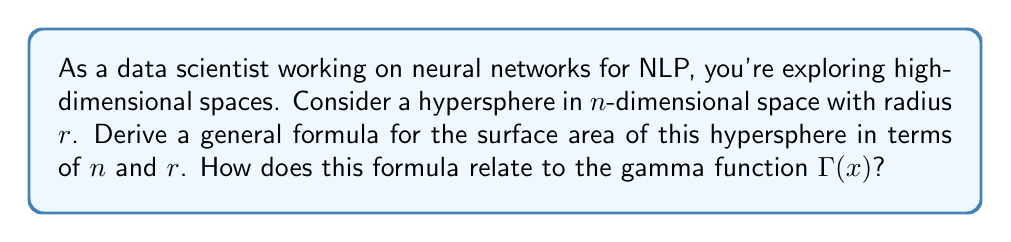Solve this math problem. To derive the surface area of a hypersphere in n-dimensional space, we'll follow these steps:

1) First, recall that the volume of a hypersphere in n-dimensions is given by:

   $$V_n(r) = \frac{\pi^{n/2}}{\Gamma(\frac{n}{2} + 1)} r^n$$

   where $\Gamma(x)$ is the gamma function.

2) The surface area of a hypersphere is the derivative of its volume with respect to radius:

   $$S_n(r) = \frac{d}{dr}V_n(r)$$

3) Applying the derivative:

   $$S_n(r) = \frac{d}{dr}\left(\frac{\pi^{n/2}}{\Gamma(\frac{n}{2} + 1)} r^n\right)$$

   $$S_n(r) = \frac{\pi^{n/2}}{\Gamma(\frac{n}{2} + 1)} \cdot n \cdot r^{n-1}$$

4) This can be simplified to:

   $$S_n(r) = \frac{n\pi^{n/2}}{\Gamma(\frac{n}{2} + 1)} r^{n-1}$$

5) The relation to the gamma function is evident in the denominator. The gamma function extends the factorial function to complex numbers, and for positive integers, $\Gamma(n) = (n-1)!$.

6) For even dimensions, we can simplify further:
   For $n = 2k$, $\Gamma(k+1) = k!$, so:

   $$S_{2k}(r) = \frac{2k\pi^k}{k!} r^{2k-1}$$

7) For odd dimensions, we use $\Gamma(\frac{1}{2}) = \sqrt{\pi}$ and the recurrence relation of the gamma function.

This formula demonstrates how the surface area of a hypersphere grows with dimension and radius, which is crucial in understanding high-dimensional spaces often encountered in neural network architectures for NLP tasks.
Answer: The surface area of a hypersphere in n-dimensional space with radius $r$ is:

$$S_n(r) = \frac{n\pi^{n/2}}{\Gamma(\frac{n}{2} + 1)} r^{n-1}$$

where $\Gamma(x)$ is the gamma function. 